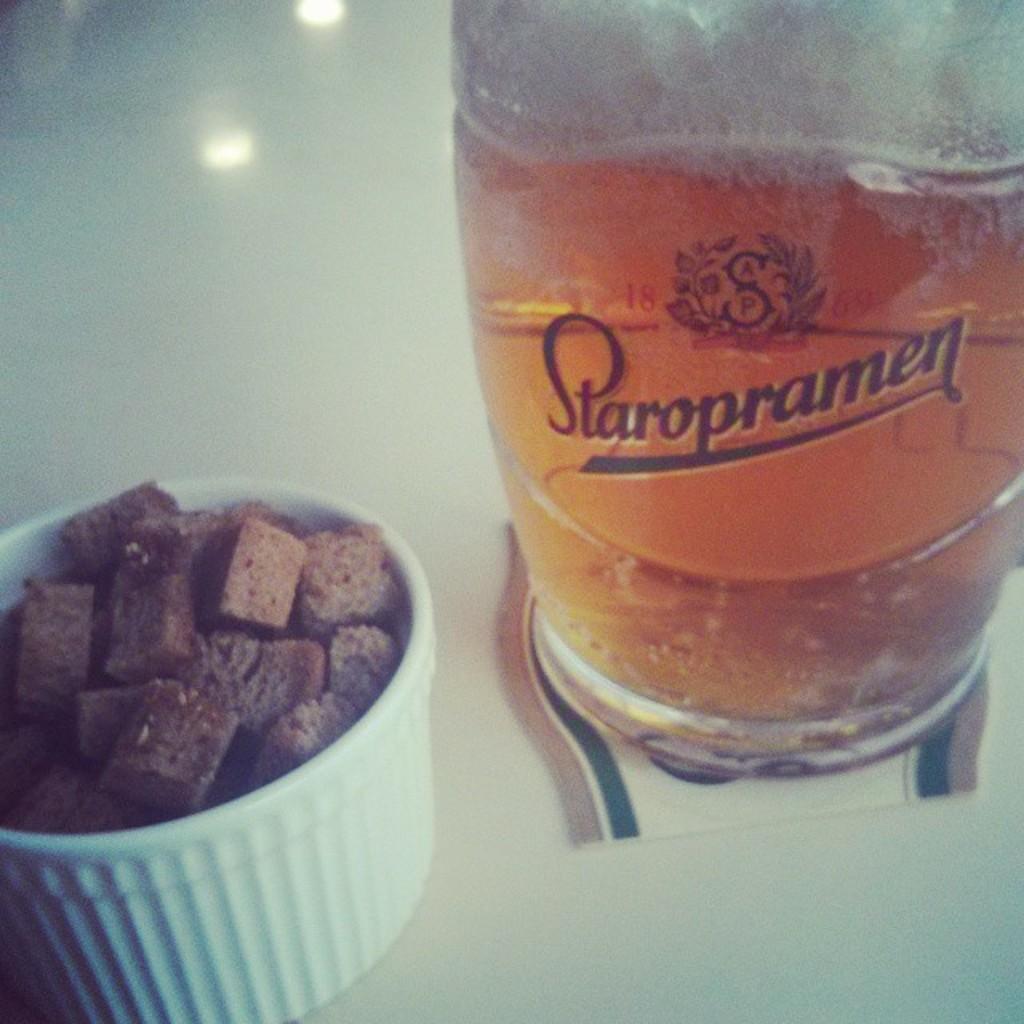Could you give a brief overview of what you see in this image? In the picture I can see a glass of wine on the right side. I can see the chocolates in the plastic bowl and it is on the bottom left side. 